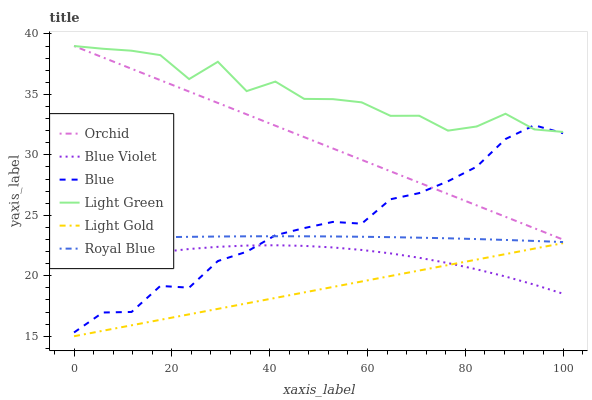Does Light Gold have the minimum area under the curve?
Answer yes or no. Yes. Does Light Green have the maximum area under the curve?
Answer yes or no. Yes. Does Royal Blue have the minimum area under the curve?
Answer yes or no. No. Does Royal Blue have the maximum area under the curve?
Answer yes or no. No. Is Light Gold the smoothest?
Answer yes or no. Yes. Is Light Green the roughest?
Answer yes or no. Yes. Is Royal Blue the smoothest?
Answer yes or no. No. Is Royal Blue the roughest?
Answer yes or no. No. Does Light Gold have the lowest value?
Answer yes or no. Yes. Does Royal Blue have the lowest value?
Answer yes or no. No. Does Orchid have the highest value?
Answer yes or no. Yes. Does Royal Blue have the highest value?
Answer yes or no. No. Is Light Gold less than Royal Blue?
Answer yes or no. Yes. Is Royal Blue greater than Light Gold?
Answer yes or no. Yes. Does Blue intersect Blue Violet?
Answer yes or no. Yes. Is Blue less than Blue Violet?
Answer yes or no. No. Is Blue greater than Blue Violet?
Answer yes or no. No. Does Light Gold intersect Royal Blue?
Answer yes or no. No. 